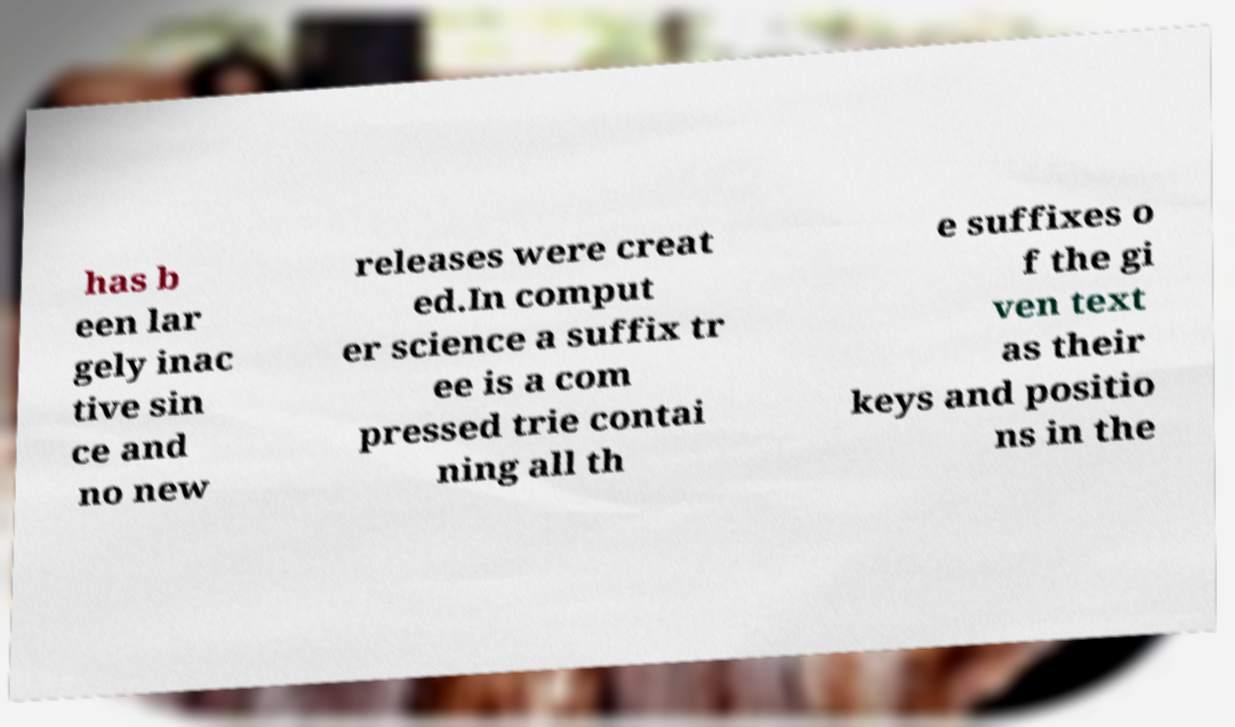Can you accurately transcribe the text from the provided image for me? has b een lar gely inac tive sin ce and no new releases were creat ed.In comput er science a suffix tr ee is a com pressed trie contai ning all th e suffixes o f the gi ven text as their keys and positio ns in the 